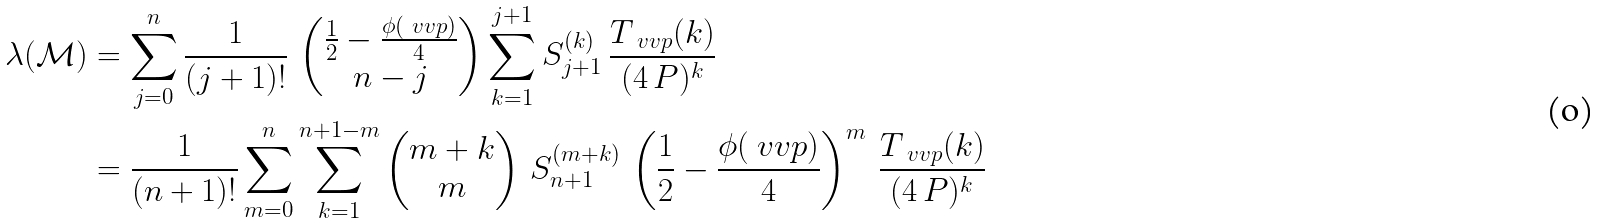<formula> <loc_0><loc_0><loc_500><loc_500>\lambda ( \mathcal { M } ) & = \sum _ { j = 0 } ^ { n } \frac { 1 } { ( j + 1 ) ! } \, \begin{pmatrix} \frac { 1 } { 2 } - \frac { \phi ( \ v v { p } ) } { 4 } \\ n - j \end{pmatrix} \sum _ { k = 1 } ^ { j + 1 } S _ { j + 1 } ^ { ( k ) } \, \frac { T _ { \ v v { p } } ( k ) } { ( 4 \, P ) ^ { k } } \\ & = \frac { 1 } { ( n + 1 ) ! } \sum _ { m = 0 } ^ { n } \sum _ { k = 1 } ^ { n + 1 - m } \begin{pmatrix} m + k \\ m \end{pmatrix} \, S _ { n + 1 } ^ { ( m + k ) } \, \left ( \frac { 1 } { 2 } - \frac { \phi ( \ v v { p } ) } { 4 } \right ) ^ { m } \, \frac { T _ { \ v v { p } } ( k ) } { ( 4 \, P ) ^ { k } }</formula> 